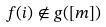Convert formula to latex. <formula><loc_0><loc_0><loc_500><loc_500>f ( i ) \notin g ( [ m ] )</formula> 